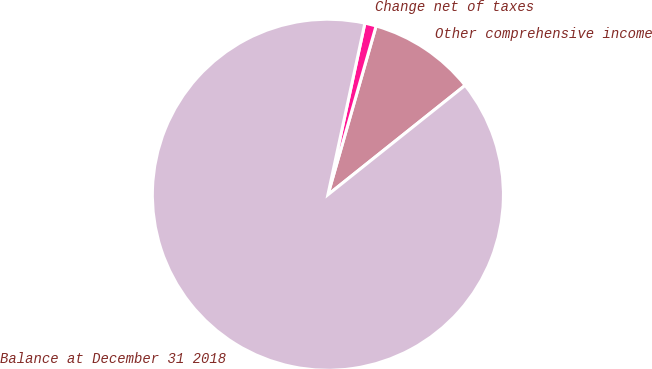Convert chart. <chart><loc_0><loc_0><loc_500><loc_500><pie_chart><fcel>Other comprehensive income<fcel>Change net of taxes<fcel>Balance at December 31 2018<nl><fcel>9.86%<fcel>1.05%<fcel>89.09%<nl></chart> 